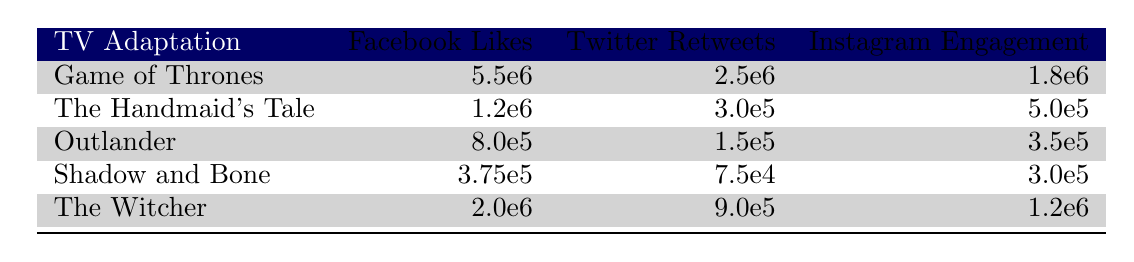What are the Facebook likes for "The Witcher"? The table lists the social media engagement for each show. Under "Facebook Likes," the value for "The Witcher" is provided as 2,000,000.
Answer: 2,000,000 Which television adaptation has the highest number of Twitter retweets? By examining the "Twitter Retweets" column, we see "Game of Thrones" has 2,500,000 retweets, which is more than any other show listed.
Answer: Game of Thrones What is the total number of Instagram engagements across all adaptations? Adding up the Instagram engagements: 1,800,000 (Game of Thrones) + 500,000 (The Handmaid's Tale) + 350,000 (Outlander) + 300,000 (Shadow and Bone) + 1,200,000 (The Witcher) gives us a total of 4,150,000.
Answer: 4,150,000 Is it true that "Shadow and Bone" has more Facebook likes than "Outlander"? "Shadow and Bone" has 375,000 Facebook likes, while "Outlander" has 800,000. Therefore, it is false that Shadow and Bone has more likes.
Answer: No What is the average number of Facebook likes for the adaptations listed? There are five adaptations. The total number of Facebook likes is 5,500,000 + 1,200,000 + 800,000 + 375,000 + 2,000,000 = 10,875,000. Dividing this total by 5 gives an average of 2,175,000.
Answer: 2,175,000 Which adaptation falls exactly in the middle of the list based on Instagram engagement? The adaptations sorted by Instagram engagement are: Shadow and Bone (300,000), Outlander (350,000), The Handmaid's Tale (500,000), The Witcher (1,200,000), and Game of Thrones (1,800,000). The middle value is "The Handmaid's Tale."
Answer: The Handmaid's Tale How much higher are the Twitter retweets for "Game of Thrones" compared to "The Handmaid's Tale"? The Twitter retweets for "Game of Thrones" are 2,500,000 and for "The Handmaid's Tale" are 300,000. The difference is 2,500,000 - 300,000 = 2,200,000.
Answer: 2,200,000 What percentage of total Facebook likes does "Game of Thrones" represent among all adaptations? The total Facebook likes are 10,875,000. "Game of Thrones" has 5,500,000 likes. The percentage is (5,500,000 / 10,875,000) * 100 = approximately 50.6%.
Answer: 50.6% 